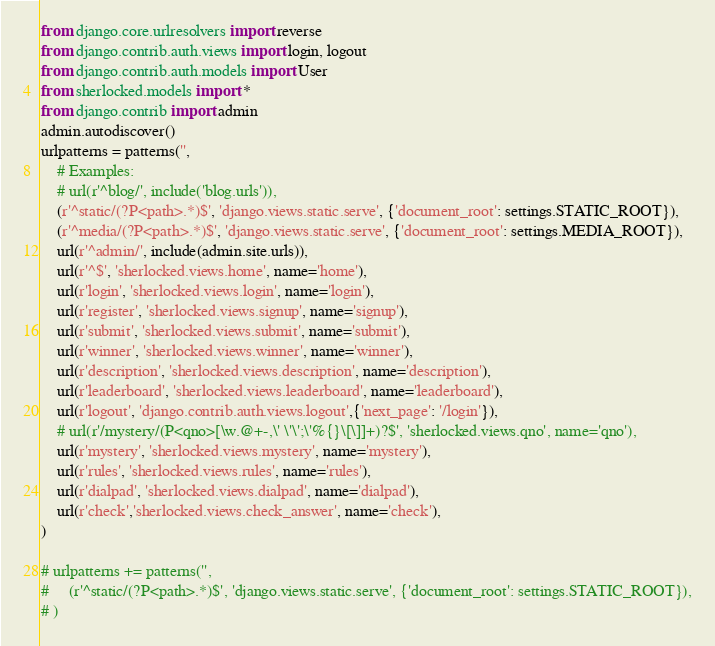Convert code to text. <code><loc_0><loc_0><loc_500><loc_500><_Python_>from django.core.urlresolvers import reverse
from django.contrib.auth.views import login, logout
from django.contrib.auth.models import User
from sherlocked.models import *
from django.contrib import admin
admin.autodiscover()
urlpatterns = patterns('',
    # Examples:
    # url(r'^blog/', include('blog.urls')),
    (r'^static/(?P<path>.*)$', 'django.views.static.serve', {'document_root': settings.STATIC_ROOT}),
    (r'^media/(?P<path>.*)$', 'django.views.static.serve', {'document_root': settings.MEDIA_ROOT}),
    url(r'^admin/', include(admin.site.urls)),
    url(r'^$', 'sherlocked.views.home', name='home'),
    url(r'login', 'sherlocked.views.login', name='login'),
    url(r'register', 'sherlocked.views.signup', name='signup'),
    url(r'submit', 'sherlocked.views.submit', name='submit'),
    url(r'winner', 'sherlocked.views.winner', name='winner'),
    url(r'description', 'sherlocked.views.description', name='description'),
    url(r'leaderboard', 'sherlocked.views.leaderboard', name='leaderboard'),
    url(r'logout', 'django.contrib.auth.views.logout',{'next_page': '/login'}),
    # url(r'/mystery/(P<qno>[\w.@+-,\' \'\';\'%{}\[\]]+)?$', 'sherlocked.views.qno', name='qno'),
    url(r'mystery', 'sherlocked.views.mystery', name='mystery'),
    url(r'rules', 'sherlocked.views.rules', name='rules'),
    url(r'dialpad', 'sherlocked.views.dialpad', name='dialpad'),
    url(r'check','sherlocked.views.check_answer', name='check'), 
)

# urlpatterns += patterns('',
#     (r'^static/(?P<path>.*)$', 'django.views.static.serve', {'document_root': settings.STATIC_ROOT}),
# )</code> 